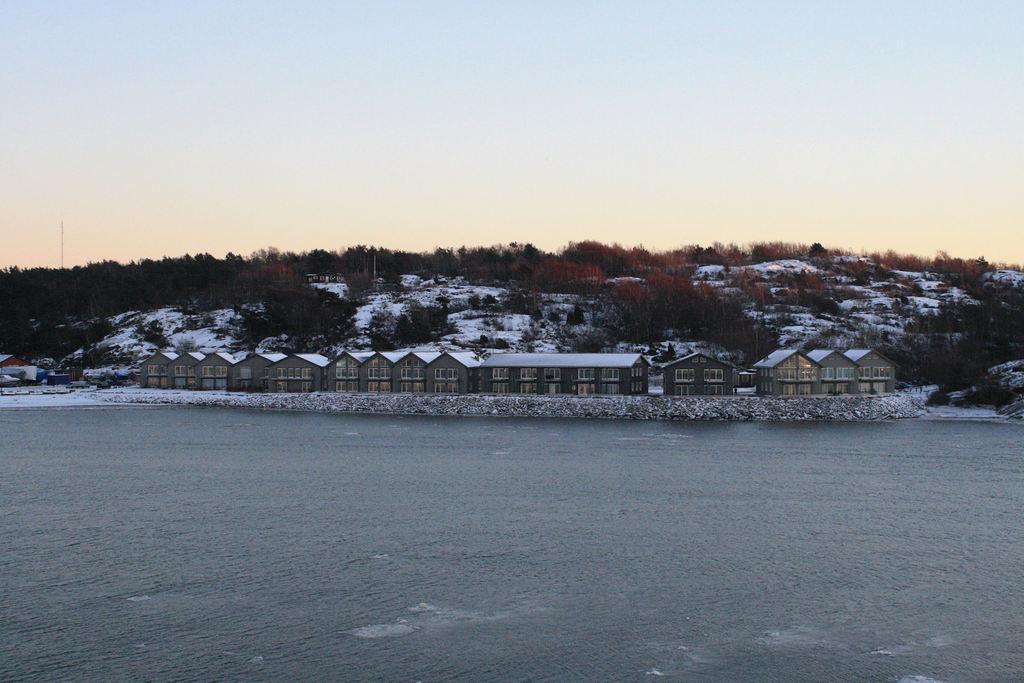Can you describe this image briefly? In the foreground I can see water, fencehouses, snow, trees, poles and mountains. At the top I can see the sky. This image is taken may be near the lake. 